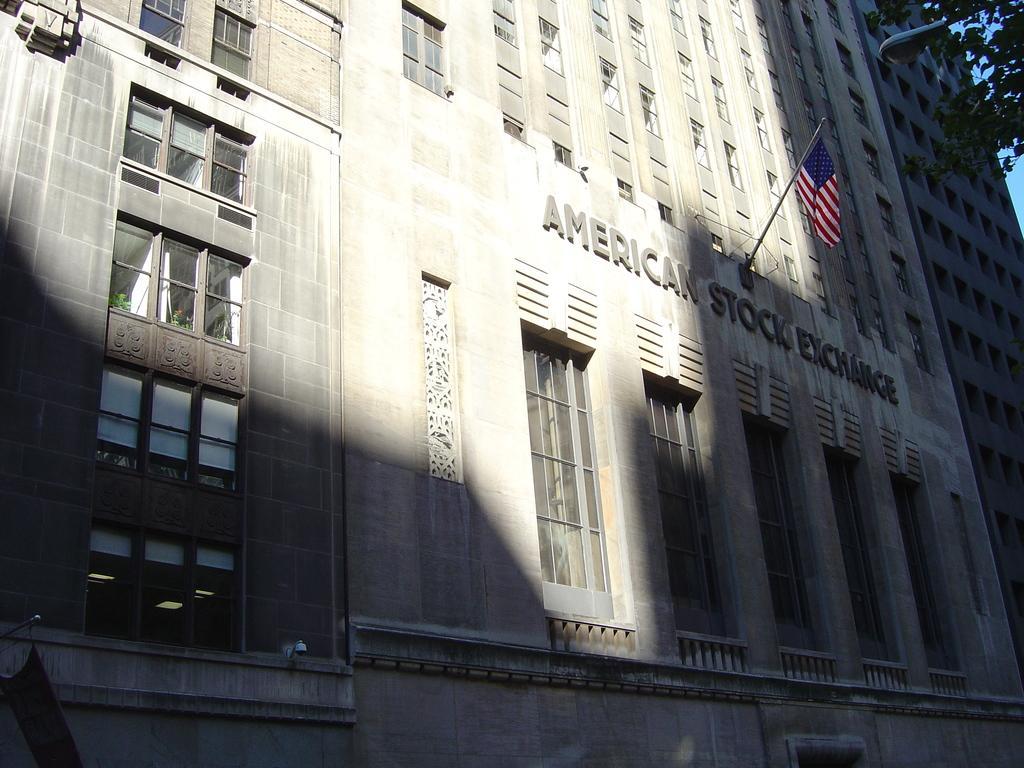What type of structure is present in the image? There is a building in the image. What feature can be observed on the building? The building has a group of windows. Is there any text visible on the building? Yes, there is text visible on the building. What else can be seen in the image besides the building? There is a pole with a flag and trees in the background of the image. What is visible in the background of the image? The sky is visible in the background of the image. Where is the pump located in the image? There is no pump present in the image. Can you tell me what the mom is doing in the image? There is no mom or any people present in the image. 